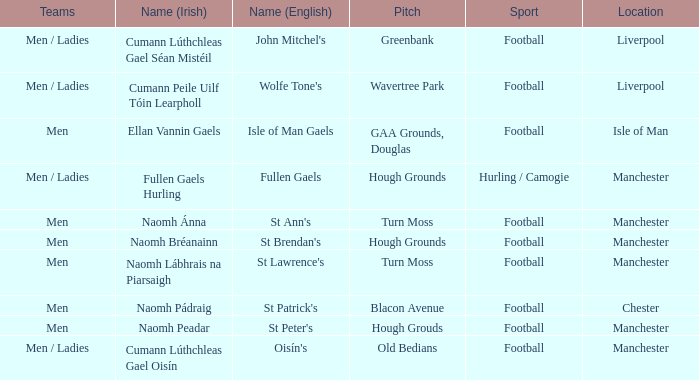What is the Location of the Old Bedians Pitch? Manchester. 